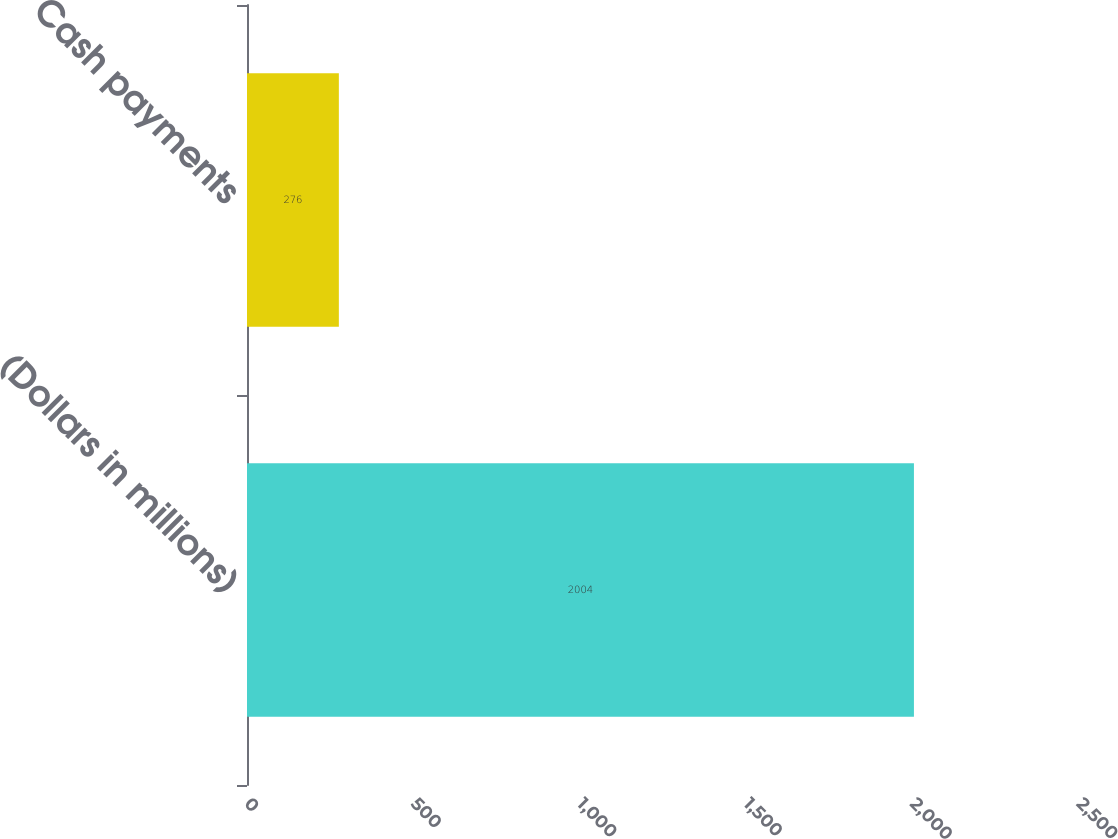<chart> <loc_0><loc_0><loc_500><loc_500><bar_chart><fcel>(Dollars in millions)<fcel>Cash payments<nl><fcel>2004<fcel>276<nl></chart> 